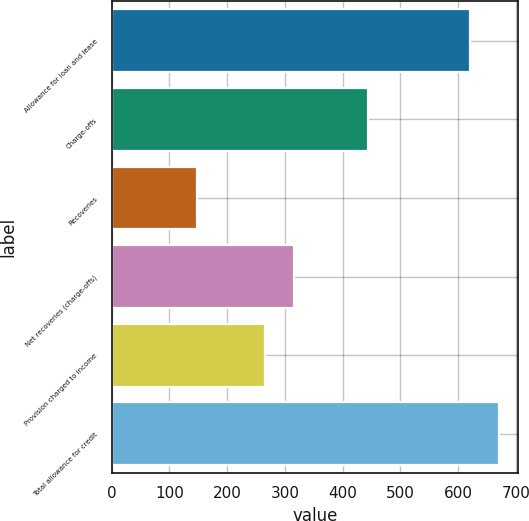<chart> <loc_0><loc_0><loc_500><loc_500><bar_chart><fcel>Allowance for loan and lease<fcel>Charge-offs<fcel>Recoveries<fcel>Net recoveries (charge-offs)<fcel>Provision charged to income<fcel>Total allowance for credit<nl><fcel>620<fcel>444<fcel>147<fcel>316.4<fcel>266<fcel>670.4<nl></chart> 